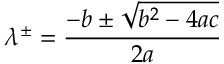Convert formula to latex. <formula><loc_0><loc_0><loc_500><loc_500>\lambda ^ { \pm } = \frac { - b \pm \sqrt { b ^ { 2 } - 4 a c } } { 2 a }</formula> 